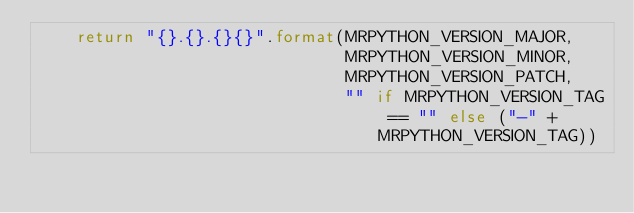<code> <loc_0><loc_0><loc_500><loc_500><_Python_>    return "{}.{}.{}{}".format(MRPYTHON_VERSION_MAJOR,
                               MRPYTHON_VERSION_MINOR,
                               MRPYTHON_VERSION_PATCH,
                               "" if MRPYTHON_VERSION_TAG == "" else ("-" + MRPYTHON_VERSION_TAG))

</code> 